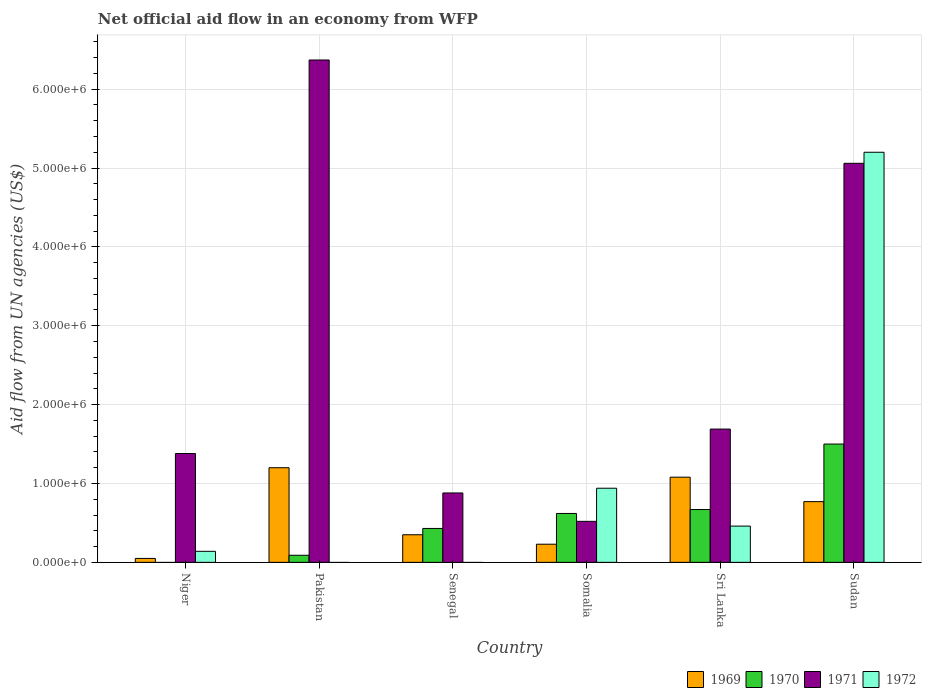What is the label of the 3rd group of bars from the left?
Provide a short and direct response. Senegal. Across all countries, what is the maximum net official aid flow in 1971?
Offer a terse response. 6.37e+06. In which country was the net official aid flow in 1970 maximum?
Make the answer very short. Sudan. What is the total net official aid flow in 1971 in the graph?
Your answer should be compact. 1.59e+07. What is the difference between the net official aid flow in 1969 in Somalia and that in Sri Lanka?
Offer a terse response. -8.50e+05. What is the difference between the net official aid flow in 1970 in Sri Lanka and the net official aid flow in 1972 in Pakistan?
Provide a short and direct response. 6.70e+05. What is the average net official aid flow in 1969 per country?
Offer a very short reply. 6.13e+05. What is the difference between the net official aid flow of/in 1970 and net official aid flow of/in 1972 in Sudan?
Ensure brevity in your answer.  -3.70e+06. In how many countries, is the net official aid flow in 1970 greater than 3200000 US$?
Ensure brevity in your answer.  0. What is the ratio of the net official aid flow in 1970 in Senegal to that in Sudan?
Ensure brevity in your answer.  0.29. Is the difference between the net official aid flow in 1970 in Somalia and Sri Lanka greater than the difference between the net official aid flow in 1972 in Somalia and Sri Lanka?
Your response must be concise. No. What is the difference between the highest and the second highest net official aid flow in 1972?
Your answer should be compact. 4.74e+06. What is the difference between the highest and the lowest net official aid flow in 1969?
Ensure brevity in your answer.  1.15e+06. Is the sum of the net official aid flow in 1972 in Niger and Somalia greater than the maximum net official aid flow in 1971 across all countries?
Offer a very short reply. No. Is it the case that in every country, the sum of the net official aid flow in 1971 and net official aid flow in 1969 is greater than the sum of net official aid flow in 1970 and net official aid flow in 1972?
Provide a succinct answer. No. How many countries are there in the graph?
Offer a very short reply. 6. What is the difference between two consecutive major ticks on the Y-axis?
Make the answer very short. 1.00e+06. How are the legend labels stacked?
Provide a succinct answer. Horizontal. What is the title of the graph?
Your answer should be compact. Net official aid flow in an economy from WFP. What is the label or title of the Y-axis?
Offer a very short reply. Aid flow from UN agencies (US$). What is the Aid flow from UN agencies (US$) in 1971 in Niger?
Provide a succinct answer. 1.38e+06. What is the Aid flow from UN agencies (US$) in 1969 in Pakistan?
Keep it short and to the point. 1.20e+06. What is the Aid flow from UN agencies (US$) of 1971 in Pakistan?
Your answer should be very brief. 6.37e+06. What is the Aid flow from UN agencies (US$) in 1972 in Pakistan?
Provide a succinct answer. 0. What is the Aid flow from UN agencies (US$) of 1969 in Senegal?
Ensure brevity in your answer.  3.50e+05. What is the Aid flow from UN agencies (US$) of 1971 in Senegal?
Your answer should be compact. 8.80e+05. What is the Aid flow from UN agencies (US$) in 1972 in Senegal?
Your response must be concise. 0. What is the Aid flow from UN agencies (US$) of 1970 in Somalia?
Make the answer very short. 6.20e+05. What is the Aid flow from UN agencies (US$) in 1971 in Somalia?
Keep it short and to the point. 5.20e+05. What is the Aid flow from UN agencies (US$) in 1972 in Somalia?
Make the answer very short. 9.40e+05. What is the Aid flow from UN agencies (US$) in 1969 in Sri Lanka?
Keep it short and to the point. 1.08e+06. What is the Aid flow from UN agencies (US$) in 1970 in Sri Lanka?
Make the answer very short. 6.70e+05. What is the Aid flow from UN agencies (US$) of 1971 in Sri Lanka?
Provide a short and direct response. 1.69e+06. What is the Aid flow from UN agencies (US$) of 1972 in Sri Lanka?
Your response must be concise. 4.60e+05. What is the Aid flow from UN agencies (US$) of 1969 in Sudan?
Provide a succinct answer. 7.70e+05. What is the Aid flow from UN agencies (US$) of 1970 in Sudan?
Provide a succinct answer. 1.50e+06. What is the Aid flow from UN agencies (US$) in 1971 in Sudan?
Provide a short and direct response. 5.06e+06. What is the Aid flow from UN agencies (US$) in 1972 in Sudan?
Your answer should be compact. 5.20e+06. Across all countries, what is the maximum Aid flow from UN agencies (US$) in 1969?
Make the answer very short. 1.20e+06. Across all countries, what is the maximum Aid flow from UN agencies (US$) of 1970?
Your response must be concise. 1.50e+06. Across all countries, what is the maximum Aid flow from UN agencies (US$) in 1971?
Provide a short and direct response. 6.37e+06. Across all countries, what is the maximum Aid flow from UN agencies (US$) in 1972?
Keep it short and to the point. 5.20e+06. Across all countries, what is the minimum Aid flow from UN agencies (US$) of 1970?
Make the answer very short. 0. Across all countries, what is the minimum Aid flow from UN agencies (US$) of 1971?
Provide a succinct answer. 5.20e+05. What is the total Aid flow from UN agencies (US$) of 1969 in the graph?
Offer a terse response. 3.68e+06. What is the total Aid flow from UN agencies (US$) in 1970 in the graph?
Your answer should be compact. 3.31e+06. What is the total Aid flow from UN agencies (US$) in 1971 in the graph?
Ensure brevity in your answer.  1.59e+07. What is the total Aid flow from UN agencies (US$) in 1972 in the graph?
Keep it short and to the point. 6.74e+06. What is the difference between the Aid flow from UN agencies (US$) of 1969 in Niger and that in Pakistan?
Make the answer very short. -1.15e+06. What is the difference between the Aid flow from UN agencies (US$) of 1971 in Niger and that in Pakistan?
Ensure brevity in your answer.  -4.99e+06. What is the difference between the Aid flow from UN agencies (US$) in 1969 in Niger and that in Senegal?
Offer a very short reply. -3.00e+05. What is the difference between the Aid flow from UN agencies (US$) in 1969 in Niger and that in Somalia?
Ensure brevity in your answer.  -1.80e+05. What is the difference between the Aid flow from UN agencies (US$) of 1971 in Niger and that in Somalia?
Provide a short and direct response. 8.60e+05. What is the difference between the Aid flow from UN agencies (US$) of 1972 in Niger and that in Somalia?
Offer a terse response. -8.00e+05. What is the difference between the Aid flow from UN agencies (US$) of 1969 in Niger and that in Sri Lanka?
Offer a terse response. -1.03e+06. What is the difference between the Aid flow from UN agencies (US$) in 1971 in Niger and that in Sri Lanka?
Provide a short and direct response. -3.10e+05. What is the difference between the Aid flow from UN agencies (US$) of 1972 in Niger and that in Sri Lanka?
Offer a very short reply. -3.20e+05. What is the difference between the Aid flow from UN agencies (US$) in 1969 in Niger and that in Sudan?
Your answer should be very brief. -7.20e+05. What is the difference between the Aid flow from UN agencies (US$) of 1971 in Niger and that in Sudan?
Your answer should be compact. -3.68e+06. What is the difference between the Aid flow from UN agencies (US$) in 1972 in Niger and that in Sudan?
Ensure brevity in your answer.  -5.06e+06. What is the difference between the Aid flow from UN agencies (US$) of 1969 in Pakistan and that in Senegal?
Offer a terse response. 8.50e+05. What is the difference between the Aid flow from UN agencies (US$) of 1971 in Pakistan and that in Senegal?
Make the answer very short. 5.49e+06. What is the difference between the Aid flow from UN agencies (US$) in 1969 in Pakistan and that in Somalia?
Provide a short and direct response. 9.70e+05. What is the difference between the Aid flow from UN agencies (US$) in 1970 in Pakistan and that in Somalia?
Keep it short and to the point. -5.30e+05. What is the difference between the Aid flow from UN agencies (US$) of 1971 in Pakistan and that in Somalia?
Your response must be concise. 5.85e+06. What is the difference between the Aid flow from UN agencies (US$) in 1970 in Pakistan and that in Sri Lanka?
Offer a very short reply. -5.80e+05. What is the difference between the Aid flow from UN agencies (US$) of 1971 in Pakistan and that in Sri Lanka?
Your response must be concise. 4.68e+06. What is the difference between the Aid flow from UN agencies (US$) in 1970 in Pakistan and that in Sudan?
Make the answer very short. -1.41e+06. What is the difference between the Aid flow from UN agencies (US$) of 1971 in Pakistan and that in Sudan?
Provide a short and direct response. 1.31e+06. What is the difference between the Aid flow from UN agencies (US$) in 1971 in Senegal and that in Somalia?
Provide a short and direct response. 3.60e+05. What is the difference between the Aid flow from UN agencies (US$) in 1969 in Senegal and that in Sri Lanka?
Offer a terse response. -7.30e+05. What is the difference between the Aid flow from UN agencies (US$) in 1971 in Senegal and that in Sri Lanka?
Your answer should be compact. -8.10e+05. What is the difference between the Aid flow from UN agencies (US$) in 1969 in Senegal and that in Sudan?
Your answer should be very brief. -4.20e+05. What is the difference between the Aid flow from UN agencies (US$) in 1970 in Senegal and that in Sudan?
Provide a short and direct response. -1.07e+06. What is the difference between the Aid flow from UN agencies (US$) of 1971 in Senegal and that in Sudan?
Offer a terse response. -4.18e+06. What is the difference between the Aid flow from UN agencies (US$) in 1969 in Somalia and that in Sri Lanka?
Your answer should be very brief. -8.50e+05. What is the difference between the Aid flow from UN agencies (US$) of 1971 in Somalia and that in Sri Lanka?
Provide a short and direct response. -1.17e+06. What is the difference between the Aid flow from UN agencies (US$) in 1972 in Somalia and that in Sri Lanka?
Offer a terse response. 4.80e+05. What is the difference between the Aid flow from UN agencies (US$) of 1969 in Somalia and that in Sudan?
Give a very brief answer. -5.40e+05. What is the difference between the Aid flow from UN agencies (US$) of 1970 in Somalia and that in Sudan?
Provide a short and direct response. -8.80e+05. What is the difference between the Aid flow from UN agencies (US$) in 1971 in Somalia and that in Sudan?
Provide a short and direct response. -4.54e+06. What is the difference between the Aid flow from UN agencies (US$) in 1972 in Somalia and that in Sudan?
Provide a succinct answer. -4.26e+06. What is the difference between the Aid flow from UN agencies (US$) in 1969 in Sri Lanka and that in Sudan?
Provide a succinct answer. 3.10e+05. What is the difference between the Aid flow from UN agencies (US$) of 1970 in Sri Lanka and that in Sudan?
Your response must be concise. -8.30e+05. What is the difference between the Aid flow from UN agencies (US$) in 1971 in Sri Lanka and that in Sudan?
Your answer should be very brief. -3.37e+06. What is the difference between the Aid flow from UN agencies (US$) of 1972 in Sri Lanka and that in Sudan?
Your answer should be compact. -4.74e+06. What is the difference between the Aid flow from UN agencies (US$) of 1969 in Niger and the Aid flow from UN agencies (US$) of 1970 in Pakistan?
Your answer should be very brief. -4.00e+04. What is the difference between the Aid flow from UN agencies (US$) in 1969 in Niger and the Aid flow from UN agencies (US$) in 1971 in Pakistan?
Give a very brief answer. -6.32e+06. What is the difference between the Aid flow from UN agencies (US$) in 1969 in Niger and the Aid flow from UN agencies (US$) in 1970 in Senegal?
Offer a very short reply. -3.80e+05. What is the difference between the Aid flow from UN agencies (US$) of 1969 in Niger and the Aid flow from UN agencies (US$) of 1971 in Senegal?
Your answer should be very brief. -8.30e+05. What is the difference between the Aid flow from UN agencies (US$) in 1969 in Niger and the Aid flow from UN agencies (US$) in 1970 in Somalia?
Your response must be concise. -5.70e+05. What is the difference between the Aid flow from UN agencies (US$) of 1969 in Niger and the Aid flow from UN agencies (US$) of 1971 in Somalia?
Ensure brevity in your answer.  -4.70e+05. What is the difference between the Aid flow from UN agencies (US$) in 1969 in Niger and the Aid flow from UN agencies (US$) in 1972 in Somalia?
Make the answer very short. -8.90e+05. What is the difference between the Aid flow from UN agencies (US$) of 1971 in Niger and the Aid flow from UN agencies (US$) of 1972 in Somalia?
Provide a succinct answer. 4.40e+05. What is the difference between the Aid flow from UN agencies (US$) of 1969 in Niger and the Aid flow from UN agencies (US$) of 1970 in Sri Lanka?
Give a very brief answer. -6.20e+05. What is the difference between the Aid flow from UN agencies (US$) of 1969 in Niger and the Aid flow from UN agencies (US$) of 1971 in Sri Lanka?
Your response must be concise. -1.64e+06. What is the difference between the Aid flow from UN agencies (US$) in 1969 in Niger and the Aid flow from UN agencies (US$) in 1972 in Sri Lanka?
Keep it short and to the point. -4.10e+05. What is the difference between the Aid flow from UN agencies (US$) of 1971 in Niger and the Aid flow from UN agencies (US$) of 1972 in Sri Lanka?
Give a very brief answer. 9.20e+05. What is the difference between the Aid flow from UN agencies (US$) of 1969 in Niger and the Aid flow from UN agencies (US$) of 1970 in Sudan?
Provide a short and direct response. -1.45e+06. What is the difference between the Aid flow from UN agencies (US$) of 1969 in Niger and the Aid flow from UN agencies (US$) of 1971 in Sudan?
Give a very brief answer. -5.01e+06. What is the difference between the Aid flow from UN agencies (US$) in 1969 in Niger and the Aid flow from UN agencies (US$) in 1972 in Sudan?
Offer a very short reply. -5.15e+06. What is the difference between the Aid flow from UN agencies (US$) in 1971 in Niger and the Aid flow from UN agencies (US$) in 1972 in Sudan?
Offer a very short reply. -3.82e+06. What is the difference between the Aid flow from UN agencies (US$) of 1969 in Pakistan and the Aid flow from UN agencies (US$) of 1970 in Senegal?
Keep it short and to the point. 7.70e+05. What is the difference between the Aid flow from UN agencies (US$) in 1970 in Pakistan and the Aid flow from UN agencies (US$) in 1971 in Senegal?
Make the answer very short. -7.90e+05. What is the difference between the Aid flow from UN agencies (US$) of 1969 in Pakistan and the Aid flow from UN agencies (US$) of 1970 in Somalia?
Provide a short and direct response. 5.80e+05. What is the difference between the Aid flow from UN agencies (US$) in 1969 in Pakistan and the Aid flow from UN agencies (US$) in 1971 in Somalia?
Keep it short and to the point. 6.80e+05. What is the difference between the Aid flow from UN agencies (US$) of 1970 in Pakistan and the Aid flow from UN agencies (US$) of 1971 in Somalia?
Provide a short and direct response. -4.30e+05. What is the difference between the Aid flow from UN agencies (US$) in 1970 in Pakistan and the Aid flow from UN agencies (US$) in 1972 in Somalia?
Provide a succinct answer. -8.50e+05. What is the difference between the Aid flow from UN agencies (US$) in 1971 in Pakistan and the Aid flow from UN agencies (US$) in 1972 in Somalia?
Keep it short and to the point. 5.43e+06. What is the difference between the Aid flow from UN agencies (US$) in 1969 in Pakistan and the Aid flow from UN agencies (US$) in 1970 in Sri Lanka?
Give a very brief answer. 5.30e+05. What is the difference between the Aid flow from UN agencies (US$) in 1969 in Pakistan and the Aid flow from UN agencies (US$) in 1971 in Sri Lanka?
Keep it short and to the point. -4.90e+05. What is the difference between the Aid flow from UN agencies (US$) in 1969 in Pakistan and the Aid flow from UN agencies (US$) in 1972 in Sri Lanka?
Offer a terse response. 7.40e+05. What is the difference between the Aid flow from UN agencies (US$) in 1970 in Pakistan and the Aid flow from UN agencies (US$) in 1971 in Sri Lanka?
Make the answer very short. -1.60e+06. What is the difference between the Aid flow from UN agencies (US$) in 1970 in Pakistan and the Aid flow from UN agencies (US$) in 1972 in Sri Lanka?
Keep it short and to the point. -3.70e+05. What is the difference between the Aid flow from UN agencies (US$) of 1971 in Pakistan and the Aid flow from UN agencies (US$) of 1972 in Sri Lanka?
Offer a terse response. 5.91e+06. What is the difference between the Aid flow from UN agencies (US$) of 1969 in Pakistan and the Aid flow from UN agencies (US$) of 1970 in Sudan?
Your response must be concise. -3.00e+05. What is the difference between the Aid flow from UN agencies (US$) in 1969 in Pakistan and the Aid flow from UN agencies (US$) in 1971 in Sudan?
Offer a terse response. -3.86e+06. What is the difference between the Aid flow from UN agencies (US$) of 1970 in Pakistan and the Aid flow from UN agencies (US$) of 1971 in Sudan?
Provide a short and direct response. -4.97e+06. What is the difference between the Aid flow from UN agencies (US$) of 1970 in Pakistan and the Aid flow from UN agencies (US$) of 1972 in Sudan?
Offer a very short reply. -5.11e+06. What is the difference between the Aid flow from UN agencies (US$) of 1971 in Pakistan and the Aid flow from UN agencies (US$) of 1972 in Sudan?
Your answer should be very brief. 1.17e+06. What is the difference between the Aid flow from UN agencies (US$) in 1969 in Senegal and the Aid flow from UN agencies (US$) in 1970 in Somalia?
Keep it short and to the point. -2.70e+05. What is the difference between the Aid flow from UN agencies (US$) in 1969 in Senegal and the Aid flow from UN agencies (US$) in 1972 in Somalia?
Provide a succinct answer. -5.90e+05. What is the difference between the Aid flow from UN agencies (US$) of 1970 in Senegal and the Aid flow from UN agencies (US$) of 1971 in Somalia?
Your answer should be compact. -9.00e+04. What is the difference between the Aid flow from UN agencies (US$) of 1970 in Senegal and the Aid flow from UN agencies (US$) of 1972 in Somalia?
Your answer should be very brief. -5.10e+05. What is the difference between the Aid flow from UN agencies (US$) in 1969 in Senegal and the Aid flow from UN agencies (US$) in 1970 in Sri Lanka?
Provide a succinct answer. -3.20e+05. What is the difference between the Aid flow from UN agencies (US$) in 1969 in Senegal and the Aid flow from UN agencies (US$) in 1971 in Sri Lanka?
Keep it short and to the point. -1.34e+06. What is the difference between the Aid flow from UN agencies (US$) in 1969 in Senegal and the Aid flow from UN agencies (US$) in 1972 in Sri Lanka?
Ensure brevity in your answer.  -1.10e+05. What is the difference between the Aid flow from UN agencies (US$) in 1970 in Senegal and the Aid flow from UN agencies (US$) in 1971 in Sri Lanka?
Give a very brief answer. -1.26e+06. What is the difference between the Aid flow from UN agencies (US$) of 1969 in Senegal and the Aid flow from UN agencies (US$) of 1970 in Sudan?
Make the answer very short. -1.15e+06. What is the difference between the Aid flow from UN agencies (US$) of 1969 in Senegal and the Aid flow from UN agencies (US$) of 1971 in Sudan?
Provide a short and direct response. -4.71e+06. What is the difference between the Aid flow from UN agencies (US$) of 1969 in Senegal and the Aid flow from UN agencies (US$) of 1972 in Sudan?
Provide a succinct answer. -4.85e+06. What is the difference between the Aid flow from UN agencies (US$) of 1970 in Senegal and the Aid flow from UN agencies (US$) of 1971 in Sudan?
Keep it short and to the point. -4.63e+06. What is the difference between the Aid flow from UN agencies (US$) of 1970 in Senegal and the Aid flow from UN agencies (US$) of 1972 in Sudan?
Offer a very short reply. -4.77e+06. What is the difference between the Aid flow from UN agencies (US$) in 1971 in Senegal and the Aid flow from UN agencies (US$) in 1972 in Sudan?
Your response must be concise. -4.32e+06. What is the difference between the Aid flow from UN agencies (US$) in 1969 in Somalia and the Aid flow from UN agencies (US$) in 1970 in Sri Lanka?
Provide a succinct answer. -4.40e+05. What is the difference between the Aid flow from UN agencies (US$) in 1969 in Somalia and the Aid flow from UN agencies (US$) in 1971 in Sri Lanka?
Make the answer very short. -1.46e+06. What is the difference between the Aid flow from UN agencies (US$) in 1970 in Somalia and the Aid flow from UN agencies (US$) in 1971 in Sri Lanka?
Offer a very short reply. -1.07e+06. What is the difference between the Aid flow from UN agencies (US$) of 1970 in Somalia and the Aid flow from UN agencies (US$) of 1972 in Sri Lanka?
Your response must be concise. 1.60e+05. What is the difference between the Aid flow from UN agencies (US$) of 1969 in Somalia and the Aid flow from UN agencies (US$) of 1970 in Sudan?
Your answer should be very brief. -1.27e+06. What is the difference between the Aid flow from UN agencies (US$) of 1969 in Somalia and the Aid flow from UN agencies (US$) of 1971 in Sudan?
Offer a terse response. -4.83e+06. What is the difference between the Aid flow from UN agencies (US$) of 1969 in Somalia and the Aid flow from UN agencies (US$) of 1972 in Sudan?
Give a very brief answer. -4.97e+06. What is the difference between the Aid flow from UN agencies (US$) of 1970 in Somalia and the Aid flow from UN agencies (US$) of 1971 in Sudan?
Keep it short and to the point. -4.44e+06. What is the difference between the Aid flow from UN agencies (US$) in 1970 in Somalia and the Aid flow from UN agencies (US$) in 1972 in Sudan?
Offer a very short reply. -4.58e+06. What is the difference between the Aid flow from UN agencies (US$) in 1971 in Somalia and the Aid flow from UN agencies (US$) in 1972 in Sudan?
Make the answer very short. -4.68e+06. What is the difference between the Aid flow from UN agencies (US$) of 1969 in Sri Lanka and the Aid flow from UN agencies (US$) of 1970 in Sudan?
Give a very brief answer. -4.20e+05. What is the difference between the Aid flow from UN agencies (US$) of 1969 in Sri Lanka and the Aid flow from UN agencies (US$) of 1971 in Sudan?
Provide a succinct answer. -3.98e+06. What is the difference between the Aid flow from UN agencies (US$) of 1969 in Sri Lanka and the Aid flow from UN agencies (US$) of 1972 in Sudan?
Make the answer very short. -4.12e+06. What is the difference between the Aid flow from UN agencies (US$) of 1970 in Sri Lanka and the Aid flow from UN agencies (US$) of 1971 in Sudan?
Your response must be concise. -4.39e+06. What is the difference between the Aid flow from UN agencies (US$) in 1970 in Sri Lanka and the Aid flow from UN agencies (US$) in 1972 in Sudan?
Provide a succinct answer. -4.53e+06. What is the difference between the Aid flow from UN agencies (US$) of 1971 in Sri Lanka and the Aid flow from UN agencies (US$) of 1972 in Sudan?
Your response must be concise. -3.51e+06. What is the average Aid flow from UN agencies (US$) of 1969 per country?
Your answer should be very brief. 6.13e+05. What is the average Aid flow from UN agencies (US$) in 1970 per country?
Your response must be concise. 5.52e+05. What is the average Aid flow from UN agencies (US$) in 1971 per country?
Offer a terse response. 2.65e+06. What is the average Aid flow from UN agencies (US$) in 1972 per country?
Offer a terse response. 1.12e+06. What is the difference between the Aid flow from UN agencies (US$) of 1969 and Aid flow from UN agencies (US$) of 1971 in Niger?
Make the answer very short. -1.33e+06. What is the difference between the Aid flow from UN agencies (US$) in 1971 and Aid flow from UN agencies (US$) in 1972 in Niger?
Ensure brevity in your answer.  1.24e+06. What is the difference between the Aid flow from UN agencies (US$) of 1969 and Aid flow from UN agencies (US$) of 1970 in Pakistan?
Offer a very short reply. 1.11e+06. What is the difference between the Aid flow from UN agencies (US$) in 1969 and Aid flow from UN agencies (US$) in 1971 in Pakistan?
Provide a succinct answer. -5.17e+06. What is the difference between the Aid flow from UN agencies (US$) in 1970 and Aid flow from UN agencies (US$) in 1971 in Pakistan?
Offer a terse response. -6.28e+06. What is the difference between the Aid flow from UN agencies (US$) in 1969 and Aid flow from UN agencies (US$) in 1970 in Senegal?
Keep it short and to the point. -8.00e+04. What is the difference between the Aid flow from UN agencies (US$) of 1969 and Aid flow from UN agencies (US$) of 1971 in Senegal?
Your answer should be compact. -5.30e+05. What is the difference between the Aid flow from UN agencies (US$) of 1970 and Aid flow from UN agencies (US$) of 1971 in Senegal?
Your response must be concise. -4.50e+05. What is the difference between the Aid flow from UN agencies (US$) of 1969 and Aid flow from UN agencies (US$) of 1970 in Somalia?
Offer a very short reply. -3.90e+05. What is the difference between the Aid flow from UN agencies (US$) in 1969 and Aid flow from UN agencies (US$) in 1971 in Somalia?
Keep it short and to the point. -2.90e+05. What is the difference between the Aid flow from UN agencies (US$) of 1969 and Aid flow from UN agencies (US$) of 1972 in Somalia?
Make the answer very short. -7.10e+05. What is the difference between the Aid flow from UN agencies (US$) of 1970 and Aid flow from UN agencies (US$) of 1971 in Somalia?
Keep it short and to the point. 1.00e+05. What is the difference between the Aid flow from UN agencies (US$) of 1970 and Aid flow from UN agencies (US$) of 1972 in Somalia?
Provide a short and direct response. -3.20e+05. What is the difference between the Aid flow from UN agencies (US$) in 1971 and Aid flow from UN agencies (US$) in 1972 in Somalia?
Your answer should be compact. -4.20e+05. What is the difference between the Aid flow from UN agencies (US$) of 1969 and Aid flow from UN agencies (US$) of 1971 in Sri Lanka?
Your response must be concise. -6.10e+05. What is the difference between the Aid flow from UN agencies (US$) in 1969 and Aid flow from UN agencies (US$) in 1972 in Sri Lanka?
Keep it short and to the point. 6.20e+05. What is the difference between the Aid flow from UN agencies (US$) of 1970 and Aid flow from UN agencies (US$) of 1971 in Sri Lanka?
Your answer should be compact. -1.02e+06. What is the difference between the Aid flow from UN agencies (US$) in 1971 and Aid flow from UN agencies (US$) in 1972 in Sri Lanka?
Your answer should be very brief. 1.23e+06. What is the difference between the Aid flow from UN agencies (US$) in 1969 and Aid flow from UN agencies (US$) in 1970 in Sudan?
Keep it short and to the point. -7.30e+05. What is the difference between the Aid flow from UN agencies (US$) of 1969 and Aid flow from UN agencies (US$) of 1971 in Sudan?
Your response must be concise. -4.29e+06. What is the difference between the Aid flow from UN agencies (US$) of 1969 and Aid flow from UN agencies (US$) of 1972 in Sudan?
Offer a terse response. -4.43e+06. What is the difference between the Aid flow from UN agencies (US$) of 1970 and Aid flow from UN agencies (US$) of 1971 in Sudan?
Your answer should be very brief. -3.56e+06. What is the difference between the Aid flow from UN agencies (US$) of 1970 and Aid flow from UN agencies (US$) of 1972 in Sudan?
Your response must be concise. -3.70e+06. What is the difference between the Aid flow from UN agencies (US$) of 1971 and Aid flow from UN agencies (US$) of 1972 in Sudan?
Your answer should be very brief. -1.40e+05. What is the ratio of the Aid flow from UN agencies (US$) in 1969 in Niger to that in Pakistan?
Provide a succinct answer. 0.04. What is the ratio of the Aid flow from UN agencies (US$) of 1971 in Niger to that in Pakistan?
Your response must be concise. 0.22. What is the ratio of the Aid flow from UN agencies (US$) in 1969 in Niger to that in Senegal?
Your response must be concise. 0.14. What is the ratio of the Aid flow from UN agencies (US$) in 1971 in Niger to that in Senegal?
Your answer should be compact. 1.57. What is the ratio of the Aid flow from UN agencies (US$) in 1969 in Niger to that in Somalia?
Keep it short and to the point. 0.22. What is the ratio of the Aid flow from UN agencies (US$) of 1971 in Niger to that in Somalia?
Your answer should be compact. 2.65. What is the ratio of the Aid flow from UN agencies (US$) of 1972 in Niger to that in Somalia?
Your response must be concise. 0.15. What is the ratio of the Aid flow from UN agencies (US$) in 1969 in Niger to that in Sri Lanka?
Offer a very short reply. 0.05. What is the ratio of the Aid flow from UN agencies (US$) in 1971 in Niger to that in Sri Lanka?
Keep it short and to the point. 0.82. What is the ratio of the Aid flow from UN agencies (US$) of 1972 in Niger to that in Sri Lanka?
Give a very brief answer. 0.3. What is the ratio of the Aid flow from UN agencies (US$) of 1969 in Niger to that in Sudan?
Keep it short and to the point. 0.06. What is the ratio of the Aid flow from UN agencies (US$) in 1971 in Niger to that in Sudan?
Offer a very short reply. 0.27. What is the ratio of the Aid flow from UN agencies (US$) of 1972 in Niger to that in Sudan?
Provide a short and direct response. 0.03. What is the ratio of the Aid flow from UN agencies (US$) in 1969 in Pakistan to that in Senegal?
Provide a short and direct response. 3.43. What is the ratio of the Aid flow from UN agencies (US$) in 1970 in Pakistan to that in Senegal?
Ensure brevity in your answer.  0.21. What is the ratio of the Aid flow from UN agencies (US$) of 1971 in Pakistan to that in Senegal?
Keep it short and to the point. 7.24. What is the ratio of the Aid flow from UN agencies (US$) in 1969 in Pakistan to that in Somalia?
Give a very brief answer. 5.22. What is the ratio of the Aid flow from UN agencies (US$) of 1970 in Pakistan to that in Somalia?
Ensure brevity in your answer.  0.15. What is the ratio of the Aid flow from UN agencies (US$) in 1971 in Pakistan to that in Somalia?
Offer a very short reply. 12.25. What is the ratio of the Aid flow from UN agencies (US$) of 1969 in Pakistan to that in Sri Lanka?
Offer a terse response. 1.11. What is the ratio of the Aid flow from UN agencies (US$) of 1970 in Pakistan to that in Sri Lanka?
Your answer should be very brief. 0.13. What is the ratio of the Aid flow from UN agencies (US$) in 1971 in Pakistan to that in Sri Lanka?
Give a very brief answer. 3.77. What is the ratio of the Aid flow from UN agencies (US$) of 1969 in Pakistan to that in Sudan?
Make the answer very short. 1.56. What is the ratio of the Aid flow from UN agencies (US$) of 1970 in Pakistan to that in Sudan?
Give a very brief answer. 0.06. What is the ratio of the Aid flow from UN agencies (US$) in 1971 in Pakistan to that in Sudan?
Provide a succinct answer. 1.26. What is the ratio of the Aid flow from UN agencies (US$) of 1969 in Senegal to that in Somalia?
Make the answer very short. 1.52. What is the ratio of the Aid flow from UN agencies (US$) in 1970 in Senegal to that in Somalia?
Your answer should be compact. 0.69. What is the ratio of the Aid flow from UN agencies (US$) in 1971 in Senegal to that in Somalia?
Offer a very short reply. 1.69. What is the ratio of the Aid flow from UN agencies (US$) in 1969 in Senegal to that in Sri Lanka?
Your answer should be compact. 0.32. What is the ratio of the Aid flow from UN agencies (US$) in 1970 in Senegal to that in Sri Lanka?
Your response must be concise. 0.64. What is the ratio of the Aid flow from UN agencies (US$) of 1971 in Senegal to that in Sri Lanka?
Your response must be concise. 0.52. What is the ratio of the Aid flow from UN agencies (US$) in 1969 in Senegal to that in Sudan?
Offer a terse response. 0.45. What is the ratio of the Aid flow from UN agencies (US$) of 1970 in Senegal to that in Sudan?
Ensure brevity in your answer.  0.29. What is the ratio of the Aid flow from UN agencies (US$) of 1971 in Senegal to that in Sudan?
Offer a very short reply. 0.17. What is the ratio of the Aid flow from UN agencies (US$) of 1969 in Somalia to that in Sri Lanka?
Provide a short and direct response. 0.21. What is the ratio of the Aid flow from UN agencies (US$) of 1970 in Somalia to that in Sri Lanka?
Offer a very short reply. 0.93. What is the ratio of the Aid flow from UN agencies (US$) of 1971 in Somalia to that in Sri Lanka?
Ensure brevity in your answer.  0.31. What is the ratio of the Aid flow from UN agencies (US$) of 1972 in Somalia to that in Sri Lanka?
Ensure brevity in your answer.  2.04. What is the ratio of the Aid flow from UN agencies (US$) of 1969 in Somalia to that in Sudan?
Your answer should be compact. 0.3. What is the ratio of the Aid flow from UN agencies (US$) in 1970 in Somalia to that in Sudan?
Your answer should be compact. 0.41. What is the ratio of the Aid flow from UN agencies (US$) in 1971 in Somalia to that in Sudan?
Your answer should be compact. 0.1. What is the ratio of the Aid flow from UN agencies (US$) of 1972 in Somalia to that in Sudan?
Keep it short and to the point. 0.18. What is the ratio of the Aid flow from UN agencies (US$) of 1969 in Sri Lanka to that in Sudan?
Your answer should be compact. 1.4. What is the ratio of the Aid flow from UN agencies (US$) in 1970 in Sri Lanka to that in Sudan?
Keep it short and to the point. 0.45. What is the ratio of the Aid flow from UN agencies (US$) in 1971 in Sri Lanka to that in Sudan?
Keep it short and to the point. 0.33. What is the ratio of the Aid flow from UN agencies (US$) in 1972 in Sri Lanka to that in Sudan?
Your answer should be very brief. 0.09. What is the difference between the highest and the second highest Aid flow from UN agencies (US$) in 1969?
Give a very brief answer. 1.20e+05. What is the difference between the highest and the second highest Aid flow from UN agencies (US$) of 1970?
Provide a succinct answer. 8.30e+05. What is the difference between the highest and the second highest Aid flow from UN agencies (US$) of 1971?
Offer a terse response. 1.31e+06. What is the difference between the highest and the second highest Aid flow from UN agencies (US$) in 1972?
Provide a succinct answer. 4.26e+06. What is the difference between the highest and the lowest Aid flow from UN agencies (US$) of 1969?
Your response must be concise. 1.15e+06. What is the difference between the highest and the lowest Aid flow from UN agencies (US$) in 1970?
Provide a short and direct response. 1.50e+06. What is the difference between the highest and the lowest Aid flow from UN agencies (US$) of 1971?
Your answer should be very brief. 5.85e+06. What is the difference between the highest and the lowest Aid flow from UN agencies (US$) of 1972?
Give a very brief answer. 5.20e+06. 